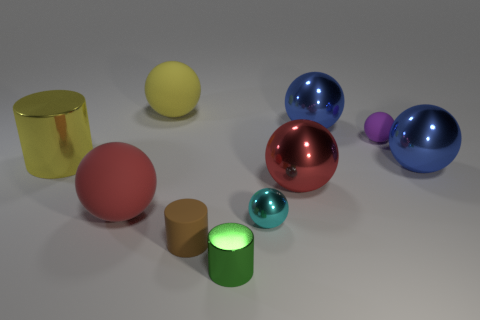Subtract all cyan spheres. How many spheres are left? 6 Subtract all purple spheres. How many spheres are left? 6 Subtract all green spheres. Subtract all yellow cylinders. How many spheres are left? 7 Subtract all balls. How many objects are left? 3 Add 3 blue balls. How many blue balls exist? 5 Subtract 0 green blocks. How many objects are left? 10 Subtract all big cyan matte cylinders. Subtract all tiny cyan things. How many objects are left? 9 Add 3 red rubber things. How many red rubber things are left? 4 